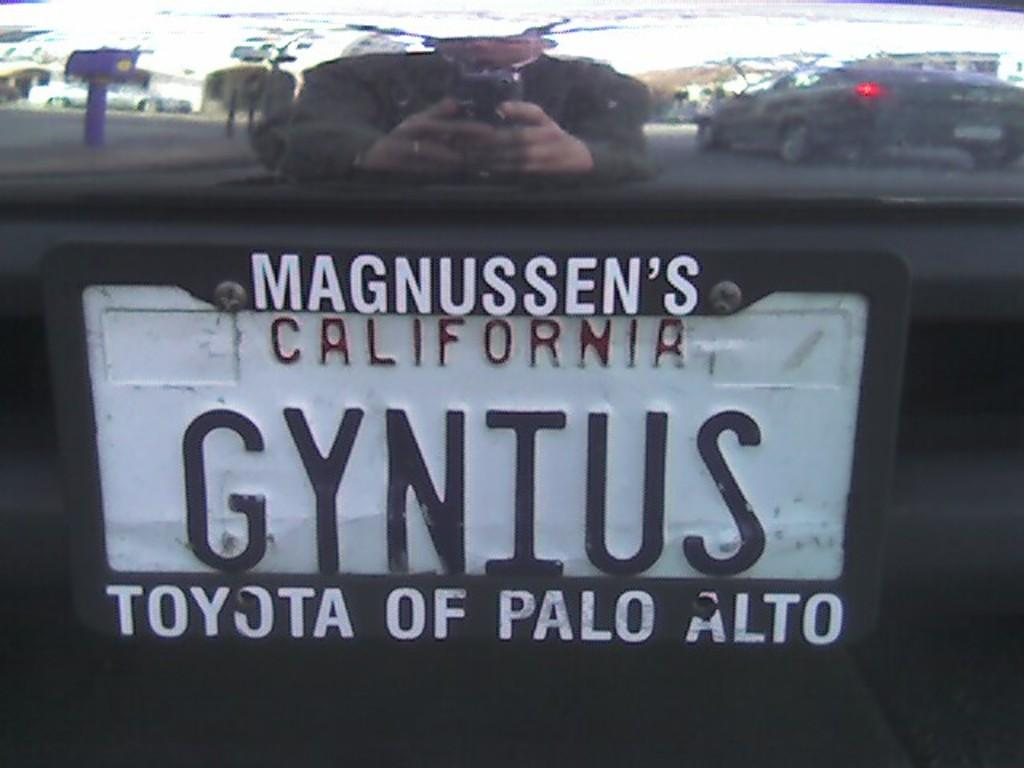<image>
Write a terse but informative summary of the picture. A California license plate has Toyota of Palo Alto written on it 